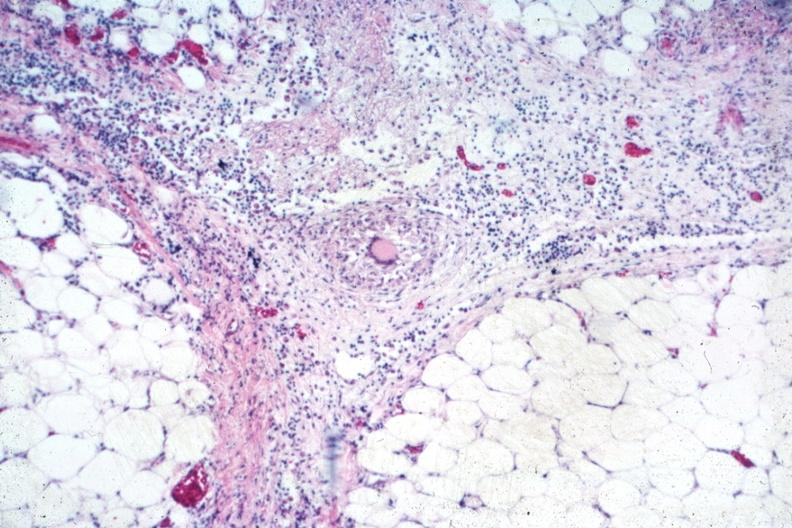s carcinomatosis endometrium primary present?
Answer the question using a single word or phrase. No 